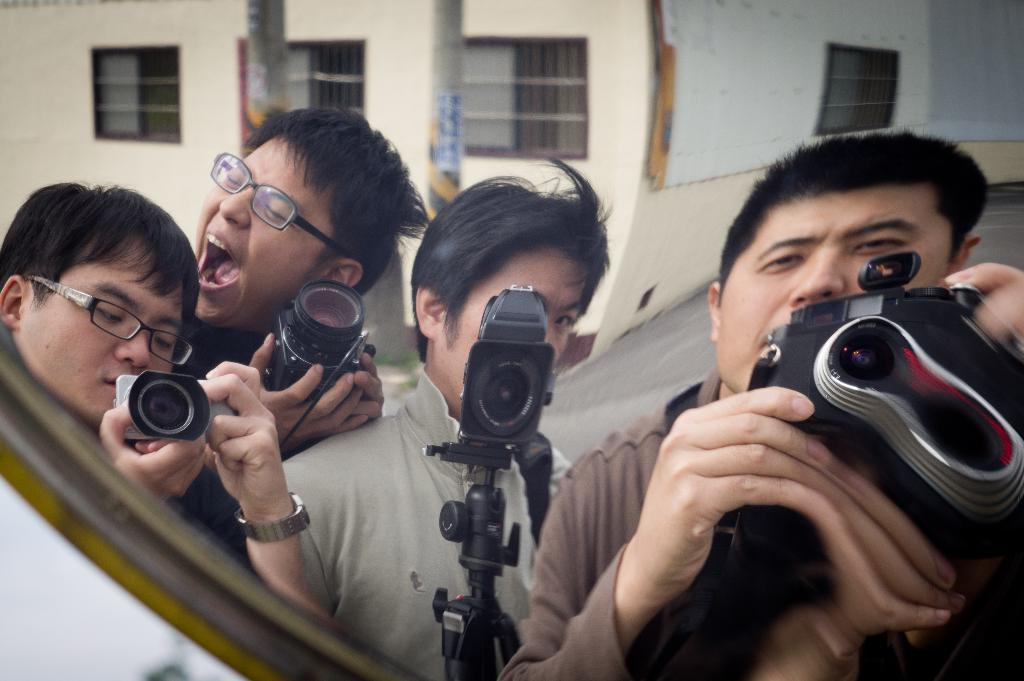How many people are in the image? There are four men in the image. What are the men doing in the image? The men are posing for a photo. What objects are the men holding in their hands? The men are holding cameras in their hands. Can you describe the appearance of any of the men? Two of the men are wearing spectacles. What can be seen in the background of the image? There is a building in the background of the image. How many cars can be seen in the image? There are no cars visible in the image; it features four men posing for a photo with cameras in their hands. What role does the mother play in the image? There is no mention of a mother in the image; it only shows four men posing for a photo. 